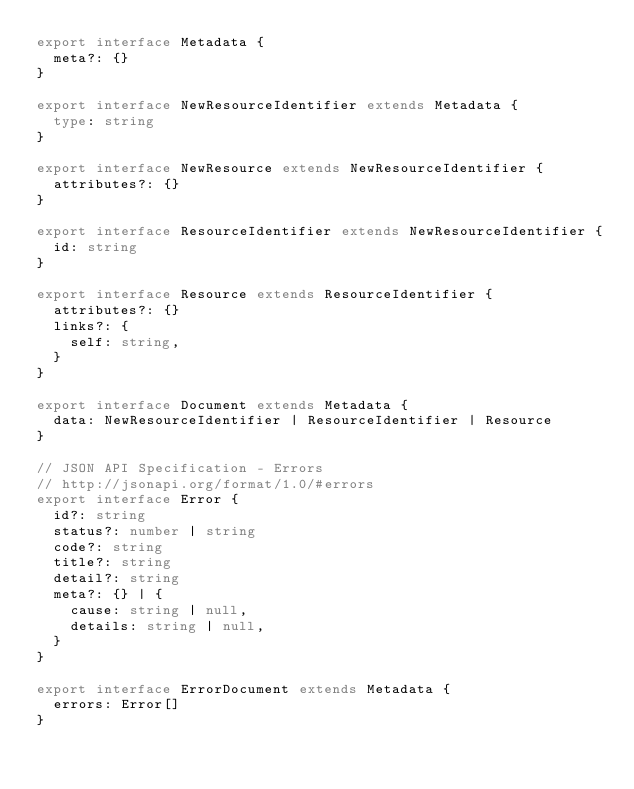<code> <loc_0><loc_0><loc_500><loc_500><_TypeScript_>export interface Metadata {
  meta?: {}
}

export interface NewResourceIdentifier extends Metadata {
  type: string
}

export interface NewResource extends NewResourceIdentifier {
  attributes?: {}
}

export interface ResourceIdentifier extends NewResourceIdentifier {
  id: string
}

export interface Resource extends ResourceIdentifier {
  attributes?: {}
  links?: {
    self: string,
  }
}

export interface Document extends Metadata {
  data: NewResourceIdentifier | ResourceIdentifier | Resource
}

// JSON API Specification - Errors
// http://jsonapi.org/format/1.0/#errors
export interface Error {
  id?: string
  status?: number | string
  code?: string
  title?: string
  detail?: string
  meta?: {} | {
    cause: string | null,
    details: string | null,
  }
}

export interface ErrorDocument extends Metadata {
  errors: Error[]
}
</code> 